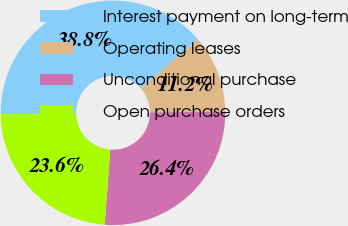Convert chart. <chart><loc_0><loc_0><loc_500><loc_500><pie_chart><fcel>Interest payment on long-term<fcel>Operating leases<fcel>Unconditional purchase<fcel>Open purchase orders<nl><fcel>38.85%<fcel>11.18%<fcel>26.37%<fcel>23.6%<nl></chart> 